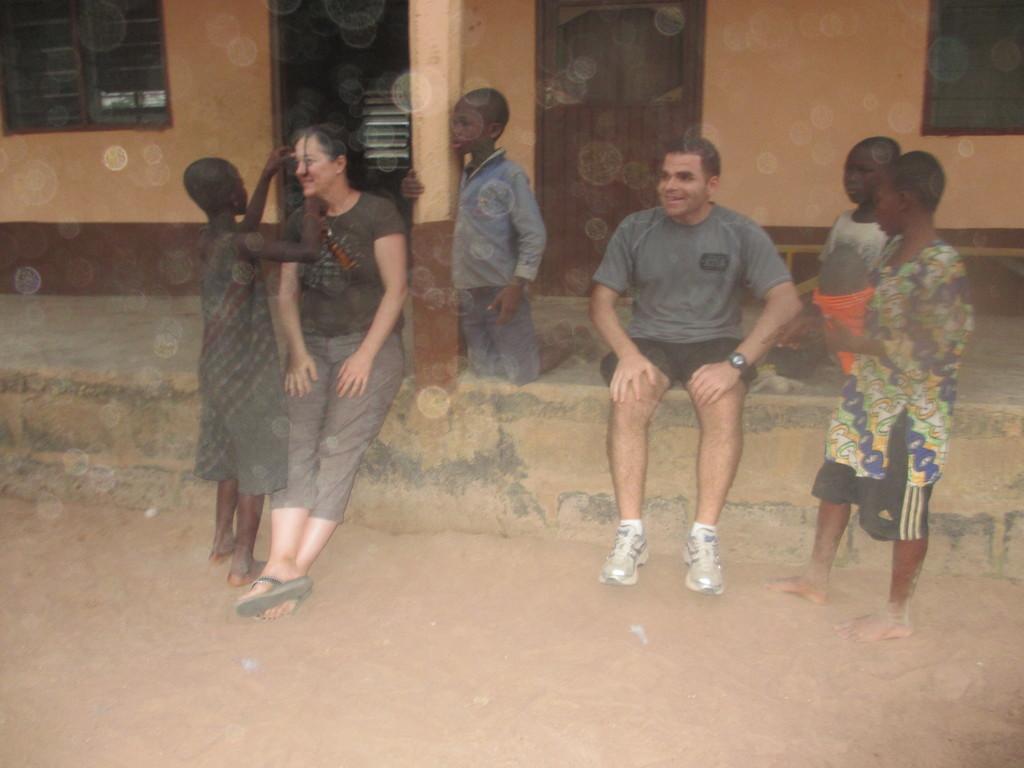Could you give a brief overview of what you see in this image? In the image there is a man and woman sitting in front of a building with few kids standing and sitting on the wall. 